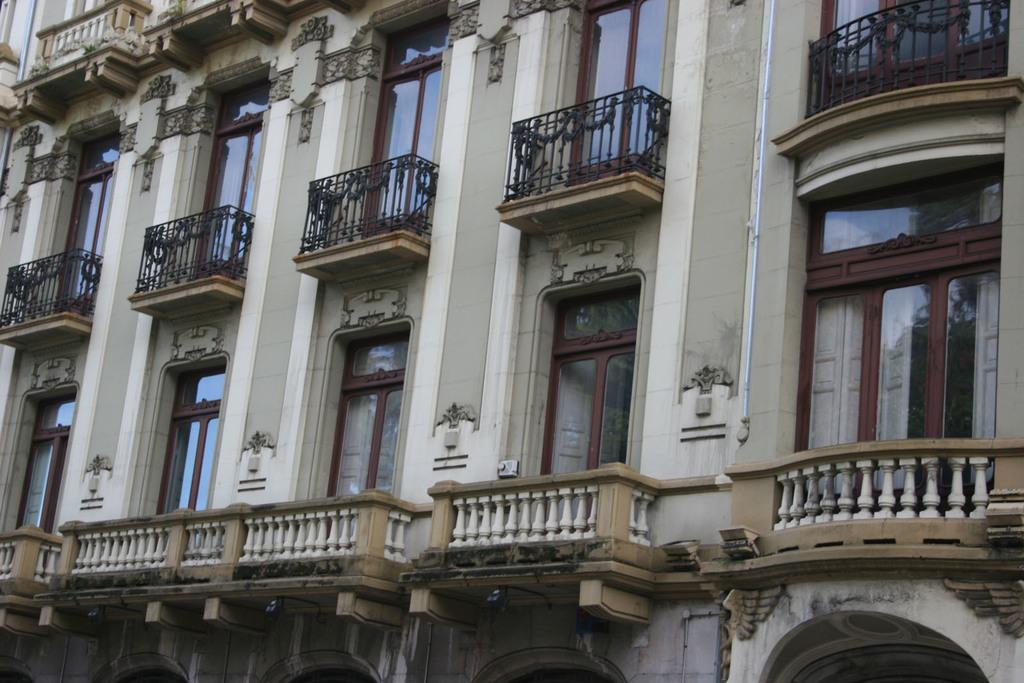What type of structure is visible in the image? There is a building in the image. What feature can be seen on the building? The building has railings. What else can be seen on the building? The building has windows. What type of glove is being used to limit the building's height in the image? There is no glove present in the image, and the building's height is not being limited. 